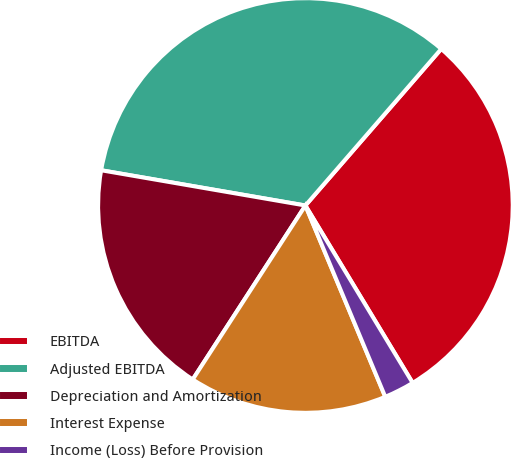Convert chart. <chart><loc_0><loc_0><loc_500><loc_500><pie_chart><fcel>EBITDA<fcel>Adjusted EBITDA<fcel>Depreciation and Amortization<fcel>Interest Expense<fcel>Income (Loss) Before Provision<nl><fcel>29.97%<fcel>33.65%<fcel>18.57%<fcel>15.44%<fcel>2.36%<nl></chart> 